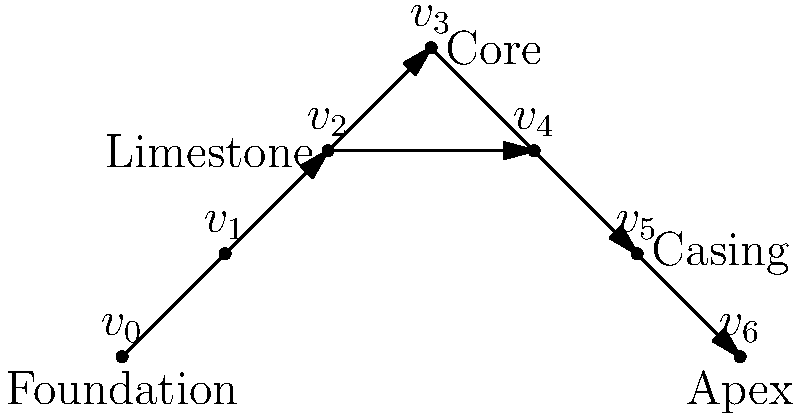In the directed acyclic graph representing the construction stages of the Great Pyramid of Giza, which vertex represents the critical step where the pyramid's core structure is completed, and how many paths lead to this vertex from the foundation? To answer this question, we need to analyze the directed acyclic graph (DAG) representing the construction stages of the Great Pyramid of Giza:

1. Identify the vertex representing the completed core structure:
   - The vertex $v_3$ is labeled "Core," indicating the completion of the pyramid's core structure.

2. Count the number of paths from the foundation ($v_0$) to the core ($v_3$):
   - Path 1: $v_0 \rightarrow v_1 \rightarrow v_2 \rightarrow v_3$
   - Path 2: $v_0 \rightarrow v_1 \rightarrow v_3$
   - Path 3: $v_0 \rightarrow v_2 \rightarrow v_3$

3. Verify that these are all possible paths:
   - The graph is acyclic, so we can't revisit vertices.
   - All edges pointing to $v_3$ have been considered.

Therefore, there are 3 distinct paths from the foundation to the completion of the core structure.
Answer: Vertex $v_3$; 3 paths 